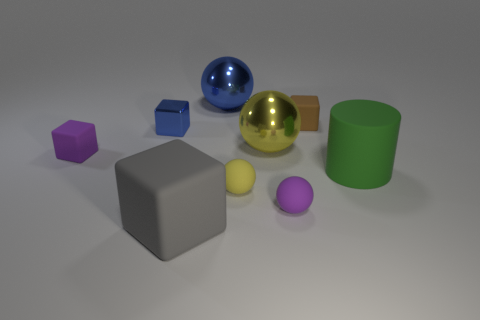How many other things are there of the same color as the metallic block? Including the metallic block, there is one other object that shares its gold color—a small spherical ball. Thus, there are a total of two items with the gold color in the image. 